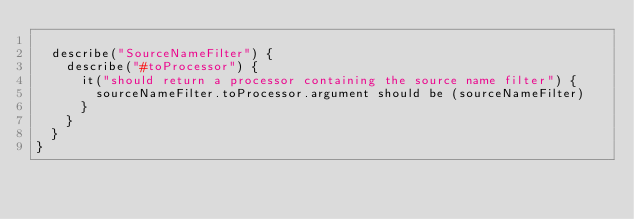<code> <loc_0><loc_0><loc_500><loc_500><_Scala_>
  describe("SourceNameFilter") {
    describe("#toProcessor") {
      it("should return a processor containing the source name filter") {
        sourceNameFilter.toProcessor.argument should be (sourceNameFilter)
      }
    }
  }
}
</code> 